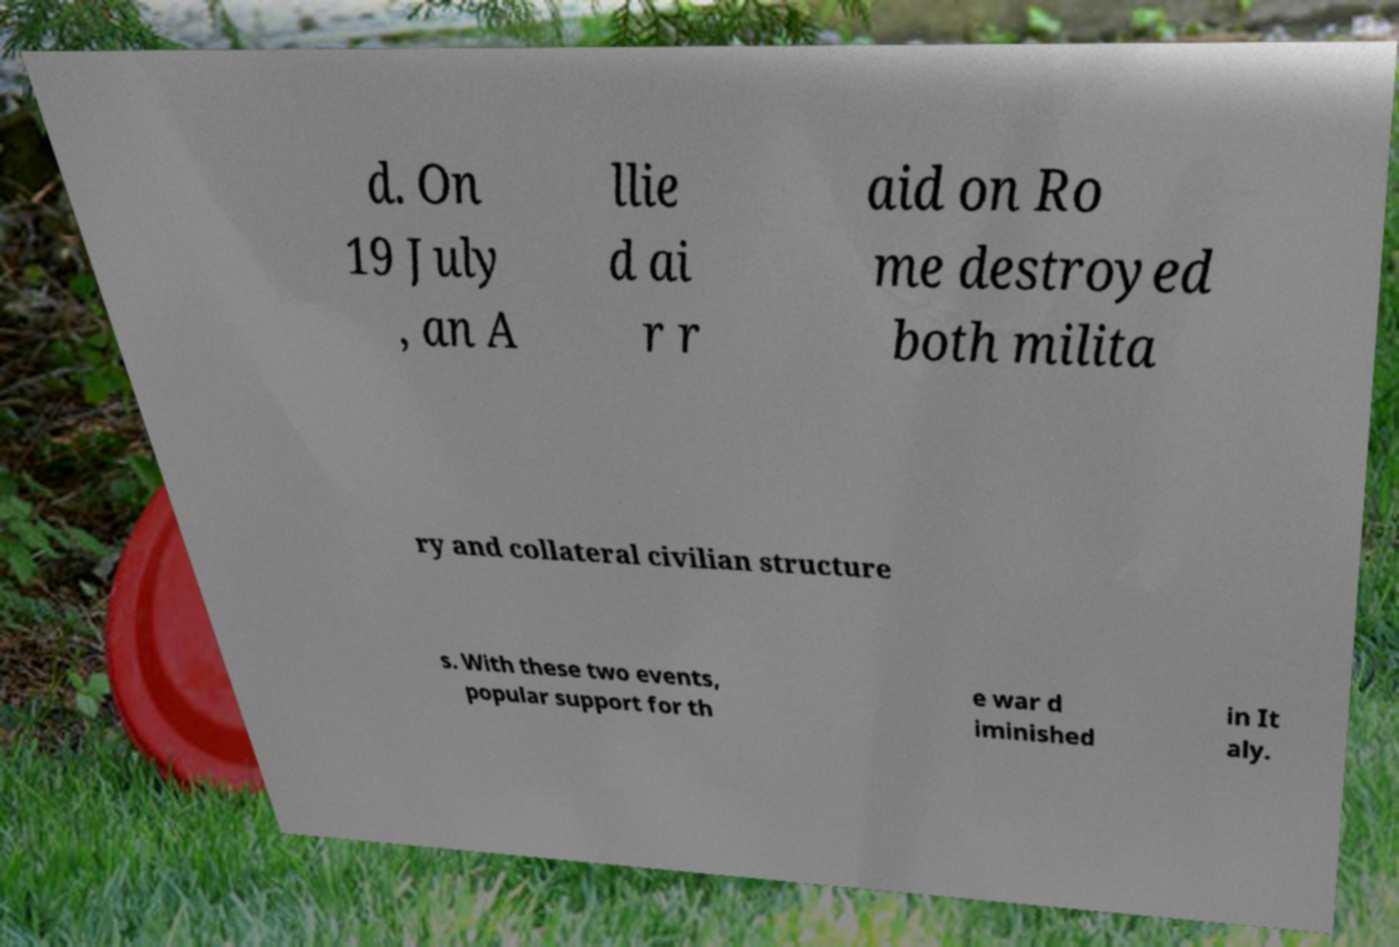Please identify and transcribe the text found in this image. d. On 19 July , an A llie d ai r r aid on Ro me destroyed both milita ry and collateral civilian structure s. With these two events, popular support for th e war d iminished in It aly. 